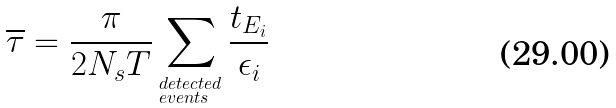<formula> <loc_0><loc_0><loc_500><loc_500>\overline { \tau } = \frac { \pi } { 2 N _ { s } T } \sum _ { ^ { d e t e c t e d } _ { e v e n t s } } \frac { t _ { E _ { i } } } { \epsilon _ { i } }</formula> 